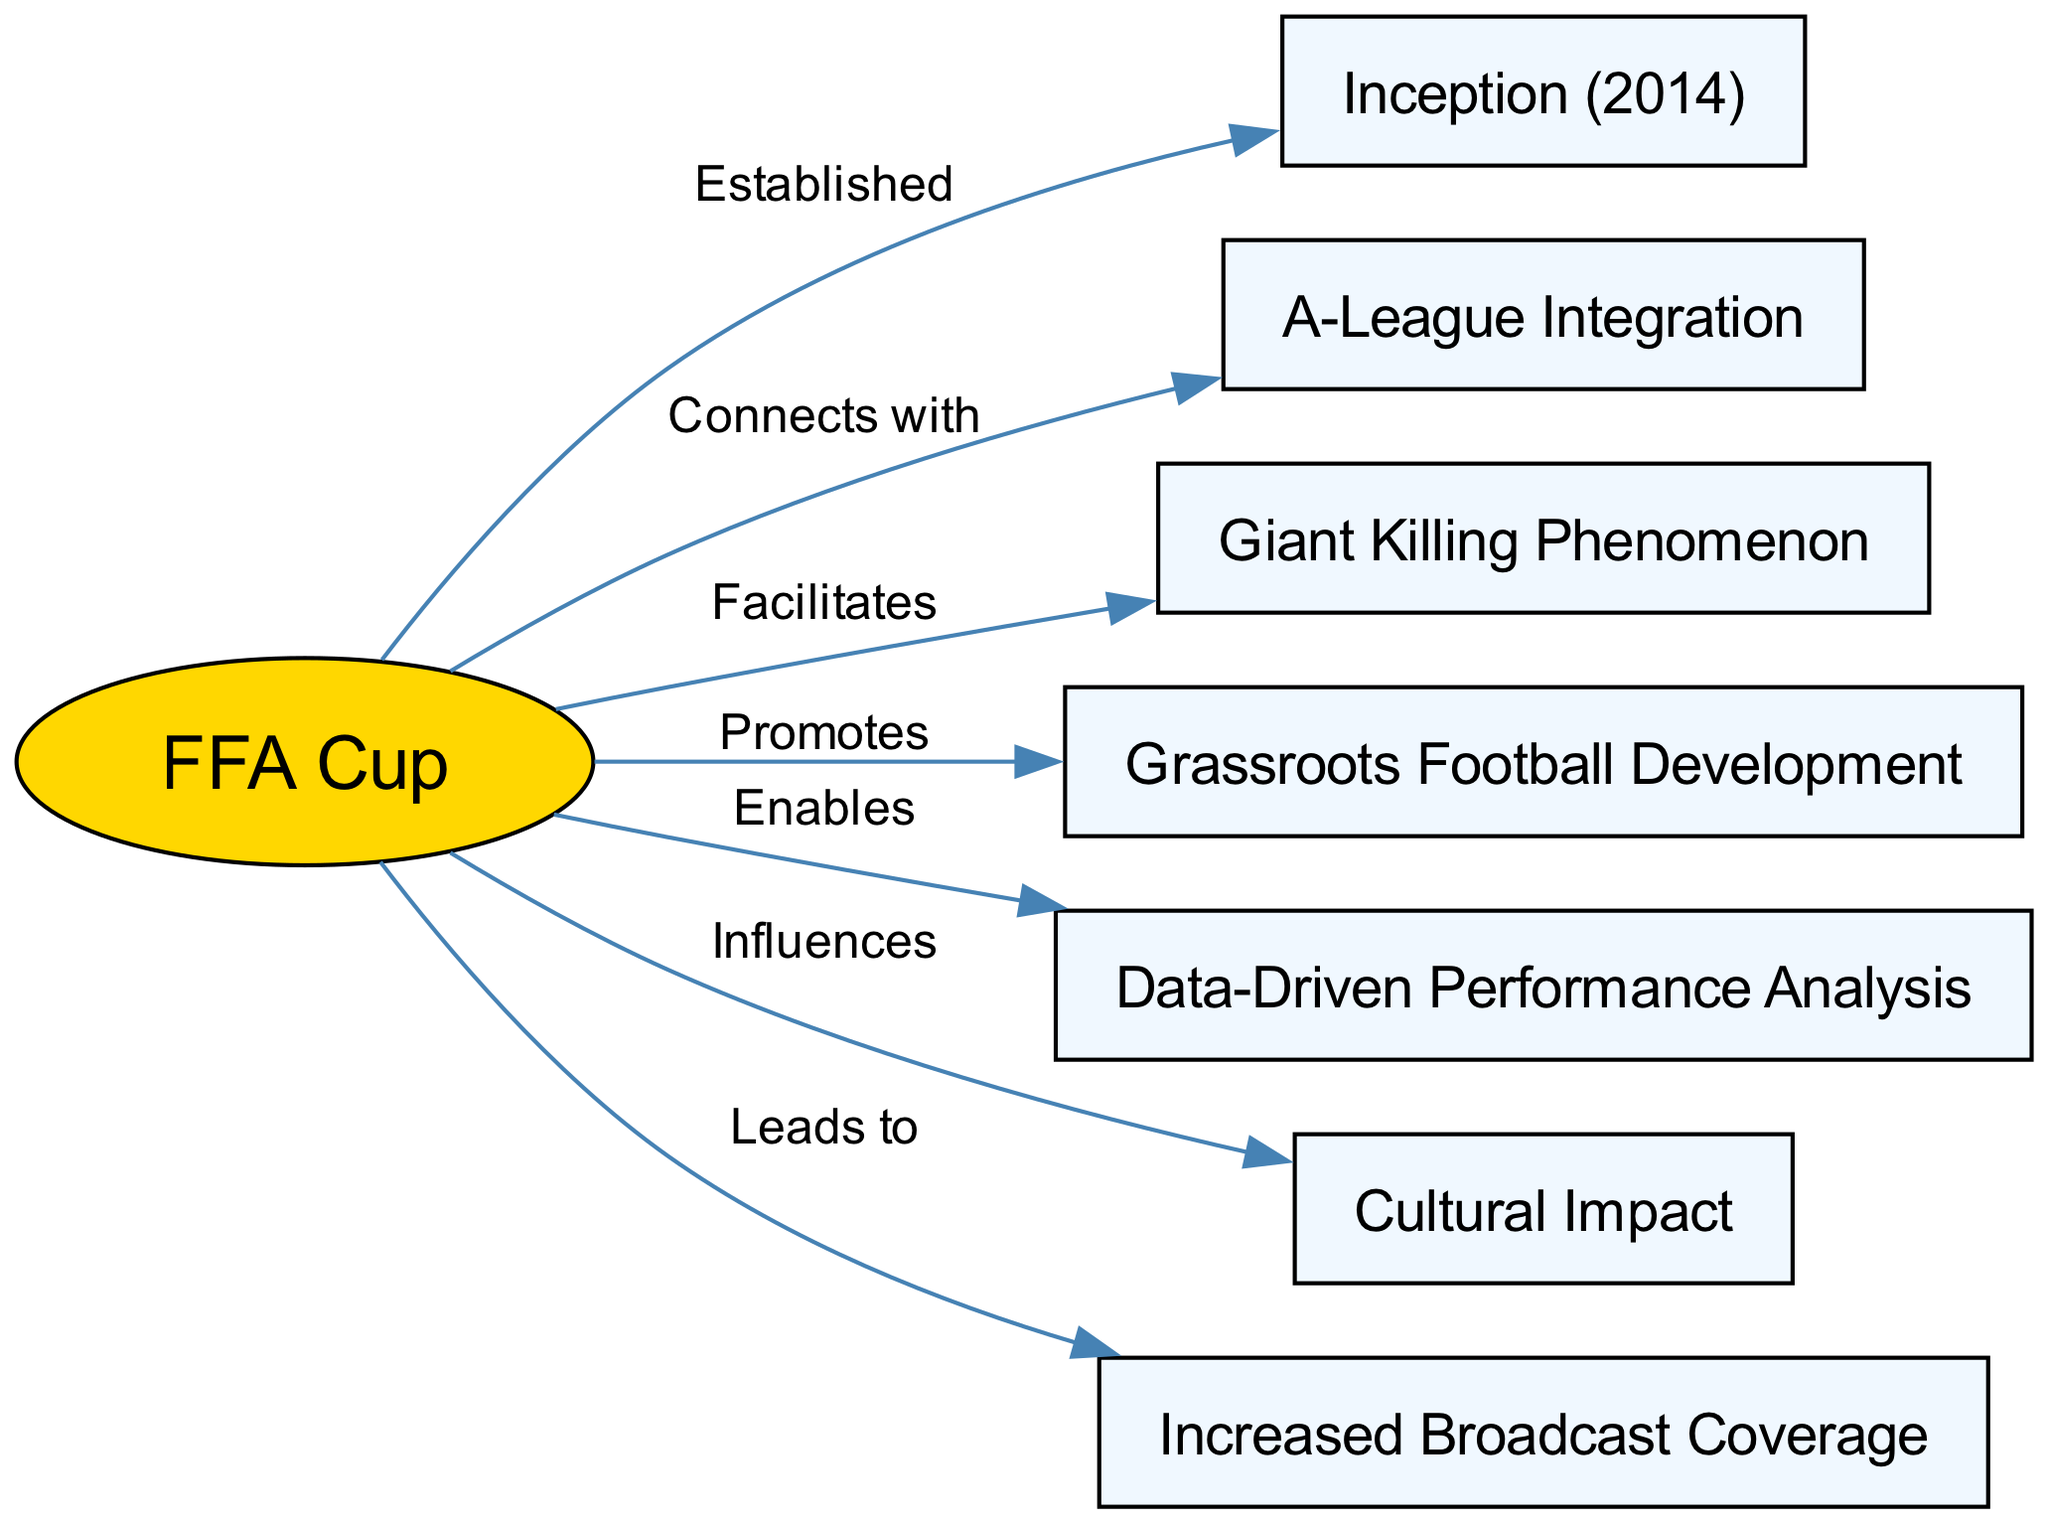What year did the FFA Cup commence? The diagram indicates that the FFA Cup was established in 2014, which is depicted in the node labeled "Inception (2014)."
Answer: 2014 How many nodes are there in the diagram? By counting the nodes listed in the diagram, we observe that there are a total of 7 nodes that include "FFA Cup," "Inception," "A-League Integration," "Giant Killing Phenomenon," "Grassroots Football Development," "Data-Driven Performance Analysis," and "Cultural Impact."
Answer: 7 What relationship does the FFA Cup have with Grassroots Football Development? The diagram describes that the FFA Cup "Promotes" Grassroots Football Development, as indicated by the connecting edge labeled with the word "Promotes."
Answer: Promotes Which node is directly connected to the FFA Cup with the label "Facilitates"? According to the diagram, the node "Giant Killing Phenomenon" is directly connected to the FFA Cup with an edge that has the label "Facilitates."
Answer: Giant Killing Phenomenon What does the edge labeled "Leads to" represent? The edge labeled "Leads to" connects the FFA Cup to the "Increased Broadcast Coverage" node, indicating that the establishment of the FFA Cup has led to increased coverage in broadcasting which emphasizes its broader visibility.
Answer: Increased Broadcast Coverage What impact does the FFA Cup have on Australian football culture according to the diagram? The diagram illustrates that the FFA Cup "Influences" Cultural Impact, suggesting a significant contribution to the overall fabric and experience of Australian football culture.
Answer: Influences How does the FFA Cup enable performance analysis? The diagram illustrates that the FFA Cup "Enables" Data-Driven Performance Analysis, implying that participation in the tournament allows for the collection and analysis of performance data.
Answer: Enables What connects the FFA Cup to A-League Integration? There is a direct relationship between the FFA Cup and A-League Integration, as shown in the diagram with an edge that connects them, labeled "Connects with."
Answer: Connects with 